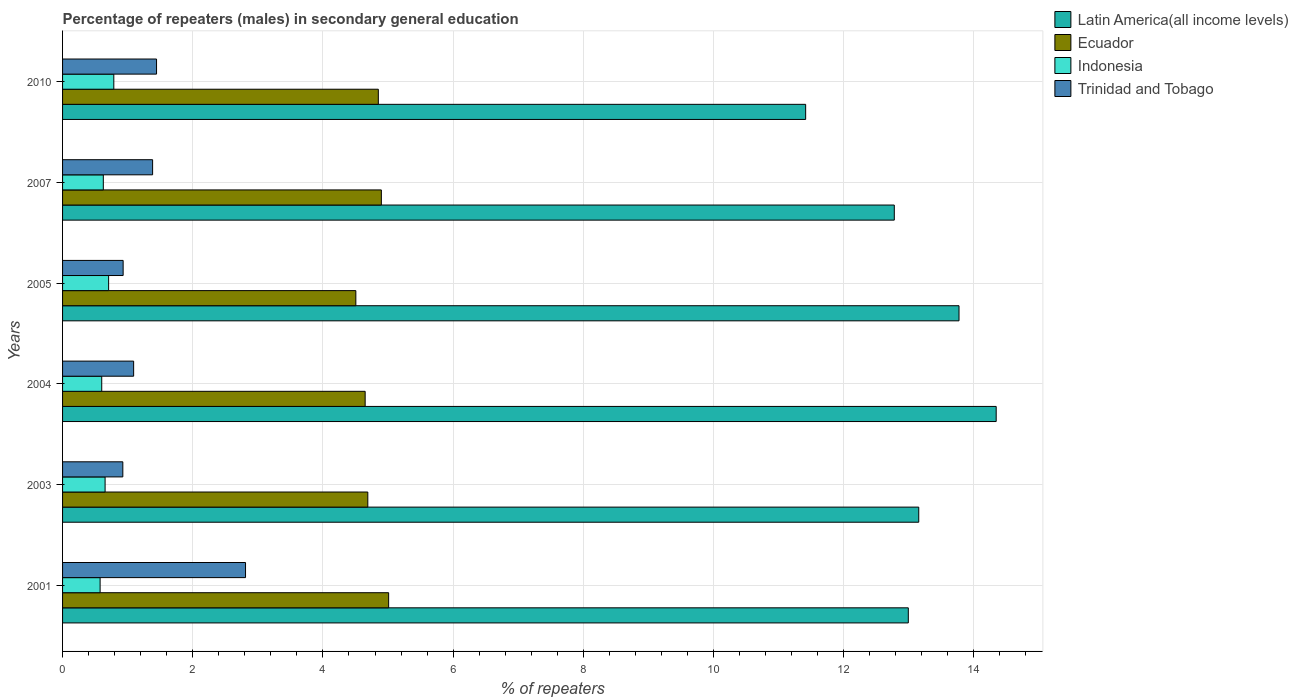How many bars are there on the 1st tick from the bottom?
Your answer should be very brief. 4. What is the label of the 4th group of bars from the top?
Offer a terse response. 2004. What is the percentage of male repeaters in Indonesia in 2004?
Provide a succinct answer. 0.6. Across all years, what is the maximum percentage of male repeaters in Indonesia?
Give a very brief answer. 0.79. Across all years, what is the minimum percentage of male repeaters in Trinidad and Tobago?
Make the answer very short. 0.93. In which year was the percentage of male repeaters in Indonesia maximum?
Offer a terse response. 2010. What is the total percentage of male repeaters in Indonesia in the graph?
Your response must be concise. 3.95. What is the difference between the percentage of male repeaters in Indonesia in 2004 and that in 2010?
Your answer should be very brief. -0.19. What is the difference between the percentage of male repeaters in Indonesia in 2004 and the percentage of male repeaters in Trinidad and Tobago in 2005?
Make the answer very short. -0.33. What is the average percentage of male repeaters in Ecuador per year?
Keep it short and to the point. 4.77. In the year 2005, what is the difference between the percentage of male repeaters in Indonesia and percentage of male repeaters in Latin America(all income levels)?
Offer a very short reply. -13.06. What is the ratio of the percentage of male repeaters in Trinidad and Tobago in 2005 to that in 2010?
Your answer should be compact. 0.64. Is the percentage of male repeaters in Trinidad and Tobago in 2003 less than that in 2005?
Provide a succinct answer. Yes. What is the difference between the highest and the second highest percentage of male repeaters in Ecuador?
Provide a succinct answer. 0.11. What is the difference between the highest and the lowest percentage of male repeaters in Indonesia?
Your response must be concise. 0.21. Is the sum of the percentage of male repeaters in Latin America(all income levels) in 2001 and 2010 greater than the maximum percentage of male repeaters in Ecuador across all years?
Offer a very short reply. Yes. Is it the case that in every year, the sum of the percentage of male repeaters in Indonesia and percentage of male repeaters in Trinidad and Tobago is greater than the sum of percentage of male repeaters in Latin America(all income levels) and percentage of male repeaters in Ecuador?
Your answer should be compact. No. What does the 4th bar from the top in 2005 represents?
Provide a succinct answer. Latin America(all income levels). What does the 2nd bar from the bottom in 2001 represents?
Ensure brevity in your answer.  Ecuador. Is it the case that in every year, the sum of the percentage of male repeaters in Ecuador and percentage of male repeaters in Latin America(all income levels) is greater than the percentage of male repeaters in Trinidad and Tobago?
Your answer should be compact. Yes. Are the values on the major ticks of X-axis written in scientific E-notation?
Keep it short and to the point. No. Does the graph contain grids?
Give a very brief answer. Yes. Where does the legend appear in the graph?
Your answer should be compact. Top right. How many legend labels are there?
Your answer should be very brief. 4. What is the title of the graph?
Make the answer very short. Percentage of repeaters (males) in secondary general education. Does "Sint Maarten (Dutch part)" appear as one of the legend labels in the graph?
Ensure brevity in your answer.  No. What is the label or title of the X-axis?
Your response must be concise. % of repeaters. What is the % of repeaters of Latin America(all income levels) in 2001?
Your response must be concise. 12.99. What is the % of repeaters of Ecuador in 2001?
Your answer should be very brief. 5.01. What is the % of repeaters in Indonesia in 2001?
Offer a terse response. 0.58. What is the % of repeaters in Trinidad and Tobago in 2001?
Your answer should be very brief. 2.81. What is the % of repeaters in Latin America(all income levels) in 2003?
Give a very brief answer. 13.15. What is the % of repeaters in Ecuador in 2003?
Offer a terse response. 4.69. What is the % of repeaters in Indonesia in 2003?
Give a very brief answer. 0.65. What is the % of repeaters in Trinidad and Tobago in 2003?
Offer a terse response. 0.93. What is the % of repeaters in Latin America(all income levels) in 2004?
Ensure brevity in your answer.  14.34. What is the % of repeaters of Ecuador in 2004?
Offer a very short reply. 4.65. What is the % of repeaters in Indonesia in 2004?
Give a very brief answer. 0.6. What is the % of repeaters in Trinidad and Tobago in 2004?
Provide a short and direct response. 1.09. What is the % of repeaters in Latin America(all income levels) in 2005?
Make the answer very short. 13.77. What is the % of repeaters in Ecuador in 2005?
Give a very brief answer. 4.51. What is the % of repeaters of Indonesia in 2005?
Provide a succinct answer. 0.71. What is the % of repeaters in Trinidad and Tobago in 2005?
Ensure brevity in your answer.  0.93. What is the % of repeaters in Latin America(all income levels) in 2007?
Give a very brief answer. 12.78. What is the % of repeaters of Ecuador in 2007?
Offer a terse response. 4.9. What is the % of repeaters of Indonesia in 2007?
Your response must be concise. 0.63. What is the % of repeaters of Trinidad and Tobago in 2007?
Keep it short and to the point. 1.38. What is the % of repeaters of Latin America(all income levels) in 2010?
Your response must be concise. 11.42. What is the % of repeaters of Ecuador in 2010?
Your response must be concise. 4.85. What is the % of repeaters in Indonesia in 2010?
Make the answer very short. 0.79. What is the % of repeaters of Trinidad and Tobago in 2010?
Provide a succinct answer. 1.44. Across all years, what is the maximum % of repeaters of Latin America(all income levels)?
Ensure brevity in your answer.  14.34. Across all years, what is the maximum % of repeaters in Ecuador?
Provide a succinct answer. 5.01. Across all years, what is the maximum % of repeaters of Indonesia?
Your answer should be compact. 0.79. Across all years, what is the maximum % of repeaters in Trinidad and Tobago?
Keep it short and to the point. 2.81. Across all years, what is the minimum % of repeaters of Latin America(all income levels)?
Your response must be concise. 11.42. Across all years, what is the minimum % of repeaters of Ecuador?
Offer a terse response. 4.51. Across all years, what is the minimum % of repeaters of Indonesia?
Offer a very short reply. 0.58. Across all years, what is the minimum % of repeaters in Trinidad and Tobago?
Provide a succinct answer. 0.93. What is the total % of repeaters of Latin America(all income levels) in the graph?
Your answer should be very brief. 78.45. What is the total % of repeaters of Ecuador in the graph?
Ensure brevity in your answer.  28.6. What is the total % of repeaters in Indonesia in the graph?
Provide a short and direct response. 3.95. What is the total % of repeaters of Trinidad and Tobago in the graph?
Ensure brevity in your answer.  8.59. What is the difference between the % of repeaters in Latin America(all income levels) in 2001 and that in 2003?
Give a very brief answer. -0.16. What is the difference between the % of repeaters of Ecuador in 2001 and that in 2003?
Offer a terse response. 0.32. What is the difference between the % of repeaters of Indonesia in 2001 and that in 2003?
Your answer should be very brief. -0.08. What is the difference between the % of repeaters in Trinidad and Tobago in 2001 and that in 2003?
Your answer should be compact. 1.89. What is the difference between the % of repeaters of Latin America(all income levels) in 2001 and that in 2004?
Offer a very short reply. -1.35. What is the difference between the % of repeaters in Ecuador in 2001 and that in 2004?
Your answer should be compact. 0.36. What is the difference between the % of repeaters in Indonesia in 2001 and that in 2004?
Provide a succinct answer. -0.03. What is the difference between the % of repeaters of Trinidad and Tobago in 2001 and that in 2004?
Your response must be concise. 1.72. What is the difference between the % of repeaters in Latin America(all income levels) in 2001 and that in 2005?
Provide a short and direct response. -0.78. What is the difference between the % of repeaters in Ecuador in 2001 and that in 2005?
Offer a very short reply. 0.5. What is the difference between the % of repeaters in Indonesia in 2001 and that in 2005?
Give a very brief answer. -0.13. What is the difference between the % of repeaters in Trinidad and Tobago in 2001 and that in 2005?
Ensure brevity in your answer.  1.88. What is the difference between the % of repeaters of Latin America(all income levels) in 2001 and that in 2007?
Provide a short and direct response. 0.22. What is the difference between the % of repeaters of Ecuador in 2001 and that in 2007?
Keep it short and to the point. 0.11. What is the difference between the % of repeaters in Indonesia in 2001 and that in 2007?
Provide a short and direct response. -0.05. What is the difference between the % of repeaters in Trinidad and Tobago in 2001 and that in 2007?
Your answer should be compact. 1.43. What is the difference between the % of repeaters in Latin America(all income levels) in 2001 and that in 2010?
Ensure brevity in your answer.  1.58. What is the difference between the % of repeaters of Ecuador in 2001 and that in 2010?
Your answer should be compact. 0.16. What is the difference between the % of repeaters of Indonesia in 2001 and that in 2010?
Keep it short and to the point. -0.21. What is the difference between the % of repeaters in Trinidad and Tobago in 2001 and that in 2010?
Ensure brevity in your answer.  1.37. What is the difference between the % of repeaters in Latin America(all income levels) in 2003 and that in 2004?
Offer a terse response. -1.19. What is the difference between the % of repeaters of Ecuador in 2003 and that in 2004?
Your answer should be compact. 0.04. What is the difference between the % of repeaters of Indonesia in 2003 and that in 2004?
Provide a succinct answer. 0.05. What is the difference between the % of repeaters in Trinidad and Tobago in 2003 and that in 2004?
Your answer should be very brief. -0.17. What is the difference between the % of repeaters in Latin America(all income levels) in 2003 and that in 2005?
Provide a succinct answer. -0.62. What is the difference between the % of repeaters of Ecuador in 2003 and that in 2005?
Make the answer very short. 0.18. What is the difference between the % of repeaters in Indonesia in 2003 and that in 2005?
Keep it short and to the point. -0.05. What is the difference between the % of repeaters in Trinidad and Tobago in 2003 and that in 2005?
Offer a very short reply. -0. What is the difference between the % of repeaters in Latin America(all income levels) in 2003 and that in 2007?
Your answer should be very brief. 0.38. What is the difference between the % of repeaters of Ecuador in 2003 and that in 2007?
Your answer should be compact. -0.21. What is the difference between the % of repeaters in Indonesia in 2003 and that in 2007?
Your response must be concise. 0.03. What is the difference between the % of repeaters of Trinidad and Tobago in 2003 and that in 2007?
Your answer should be very brief. -0.46. What is the difference between the % of repeaters in Latin America(all income levels) in 2003 and that in 2010?
Offer a terse response. 1.74. What is the difference between the % of repeaters in Ecuador in 2003 and that in 2010?
Your response must be concise. -0.16. What is the difference between the % of repeaters in Indonesia in 2003 and that in 2010?
Ensure brevity in your answer.  -0.13. What is the difference between the % of repeaters of Trinidad and Tobago in 2003 and that in 2010?
Give a very brief answer. -0.52. What is the difference between the % of repeaters in Latin America(all income levels) in 2004 and that in 2005?
Provide a succinct answer. 0.57. What is the difference between the % of repeaters of Ecuador in 2004 and that in 2005?
Your answer should be compact. 0.14. What is the difference between the % of repeaters in Indonesia in 2004 and that in 2005?
Provide a succinct answer. -0.11. What is the difference between the % of repeaters of Trinidad and Tobago in 2004 and that in 2005?
Provide a succinct answer. 0.16. What is the difference between the % of repeaters in Latin America(all income levels) in 2004 and that in 2007?
Keep it short and to the point. 1.57. What is the difference between the % of repeaters of Ecuador in 2004 and that in 2007?
Make the answer very short. -0.25. What is the difference between the % of repeaters of Indonesia in 2004 and that in 2007?
Make the answer very short. -0.02. What is the difference between the % of repeaters of Trinidad and Tobago in 2004 and that in 2007?
Provide a succinct answer. -0.29. What is the difference between the % of repeaters of Latin America(all income levels) in 2004 and that in 2010?
Offer a very short reply. 2.93. What is the difference between the % of repeaters in Ecuador in 2004 and that in 2010?
Keep it short and to the point. -0.2. What is the difference between the % of repeaters in Indonesia in 2004 and that in 2010?
Your answer should be compact. -0.19. What is the difference between the % of repeaters in Trinidad and Tobago in 2004 and that in 2010?
Your answer should be very brief. -0.35. What is the difference between the % of repeaters in Latin America(all income levels) in 2005 and that in 2007?
Offer a very short reply. 0.99. What is the difference between the % of repeaters in Ecuador in 2005 and that in 2007?
Your answer should be very brief. -0.39. What is the difference between the % of repeaters of Indonesia in 2005 and that in 2007?
Make the answer very short. 0.08. What is the difference between the % of repeaters in Trinidad and Tobago in 2005 and that in 2007?
Provide a short and direct response. -0.45. What is the difference between the % of repeaters of Latin America(all income levels) in 2005 and that in 2010?
Make the answer very short. 2.36. What is the difference between the % of repeaters of Ecuador in 2005 and that in 2010?
Your answer should be very brief. -0.35. What is the difference between the % of repeaters of Indonesia in 2005 and that in 2010?
Your response must be concise. -0.08. What is the difference between the % of repeaters of Trinidad and Tobago in 2005 and that in 2010?
Your response must be concise. -0.51. What is the difference between the % of repeaters of Latin America(all income levels) in 2007 and that in 2010?
Offer a terse response. 1.36. What is the difference between the % of repeaters in Ecuador in 2007 and that in 2010?
Provide a short and direct response. 0.05. What is the difference between the % of repeaters of Indonesia in 2007 and that in 2010?
Provide a short and direct response. -0.16. What is the difference between the % of repeaters of Trinidad and Tobago in 2007 and that in 2010?
Your answer should be compact. -0.06. What is the difference between the % of repeaters of Latin America(all income levels) in 2001 and the % of repeaters of Ecuador in 2003?
Your answer should be compact. 8.3. What is the difference between the % of repeaters of Latin America(all income levels) in 2001 and the % of repeaters of Indonesia in 2003?
Ensure brevity in your answer.  12.34. What is the difference between the % of repeaters of Latin America(all income levels) in 2001 and the % of repeaters of Trinidad and Tobago in 2003?
Your response must be concise. 12.07. What is the difference between the % of repeaters in Ecuador in 2001 and the % of repeaters in Indonesia in 2003?
Offer a terse response. 4.36. What is the difference between the % of repeaters in Ecuador in 2001 and the % of repeaters in Trinidad and Tobago in 2003?
Your response must be concise. 4.08. What is the difference between the % of repeaters in Indonesia in 2001 and the % of repeaters in Trinidad and Tobago in 2003?
Your response must be concise. -0.35. What is the difference between the % of repeaters in Latin America(all income levels) in 2001 and the % of repeaters in Ecuador in 2004?
Your answer should be compact. 8.34. What is the difference between the % of repeaters in Latin America(all income levels) in 2001 and the % of repeaters in Indonesia in 2004?
Your response must be concise. 12.39. What is the difference between the % of repeaters in Latin America(all income levels) in 2001 and the % of repeaters in Trinidad and Tobago in 2004?
Keep it short and to the point. 11.9. What is the difference between the % of repeaters in Ecuador in 2001 and the % of repeaters in Indonesia in 2004?
Keep it short and to the point. 4.41. What is the difference between the % of repeaters of Ecuador in 2001 and the % of repeaters of Trinidad and Tobago in 2004?
Offer a very short reply. 3.92. What is the difference between the % of repeaters in Indonesia in 2001 and the % of repeaters in Trinidad and Tobago in 2004?
Keep it short and to the point. -0.52. What is the difference between the % of repeaters of Latin America(all income levels) in 2001 and the % of repeaters of Ecuador in 2005?
Keep it short and to the point. 8.49. What is the difference between the % of repeaters of Latin America(all income levels) in 2001 and the % of repeaters of Indonesia in 2005?
Your answer should be compact. 12.28. What is the difference between the % of repeaters in Latin America(all income levels) in 2001 and the % of repeaters in Trinidad and Tobago in 2005?
Ensure brevity in your answer.  12.06. What is the difference between the % of repeaters of Ecuador in 2001 and the % of repeaters of Indonesia in 2005?
Make the answer very short. 4.3. What is the difference between the % of repeaters of Ecuador in 2001 and the % of repeaters of Trinidad and Tobago in 2005?
Your answer should be very brief. 4.08. What is the difference between the % of repeaters in Indonesia in 2001 and the % of repeaters in Trinidad and Tobago in 2005?
Provide a short and direct response. -0.35. What is the difference between the % of repeaters of Latin America(all income levels) in 2001 and the % of repeaters of Ecuador in 2007?
Provide a succinct answer. 8.1. What is the difference between the % of repeaters in Latin America(all income levels) in 2001 and the % of repeaters in Indonesia in 2007?
Ensure brevity in your answer.  12.37. What is the difference between the % of repeaters in Latin America(all income levels) in 2001 and the % of repeaters in Trinidad and Tobago in 2007?
Make the answer very short. 11.61. What is the difference between the % of repeaters in Ecuador in 2001 and the % of repeaters in Indonesia in 2007?
Your response must be concise. 4.38. What is the difference between the % of repeaters in Ecuador in 2001 and the % of repeaters in Trinidad and Tobago in 2007?
Offer a terse response. 3.63. What is the difference between the % of repeaters in Indonesia in 2001 and the % of repeaters in Trinidad and Tobago in 2007?
Offer a terse response. -0.81. What is the difference between the % of repeaters in Latin America(all income levels) in 2001 and the % of repeaters in Ecuador in 2010?
Offer a terse response. 8.14. What is the difference between the % of repeaters of Latin America(all income levels) in 2001 and the % of repeaters of Indonesia in 2010?
Provide a short and direct response. 12.21. What is the difference between the % of repeaters in Latin America(all income levels) in 2001 and the % of repeaters in Trinidad and Tobago in 2010?
Your answer should be very brief. 11.55. What is the difference between the % of repeaters in Ecuador in 2001 and the % of repeaters in Indonesia in 2010?
Your response must be concise. 4.22. What is the difference between the % of repeaters of Ecuador in 2001 and the % of repeaters of Trinidad and Tobago in 2010?
Your answer should be compact. 3.57. What is the difference between the % of repeaters of Indonesia in 2001 and the % of repeaters of Trinidad and Tobago in 2010?
Your answer should be very brief. -0.87. What is the difference between the % of repeaters of Latin America(all income levels) in 2003 and the % of repeaters of Ecuador in 2004?
Ensure brevity in your answer.  8.5. What is the difference between the % of repeaters in Latin America(all income levels) in 2003 and the % of repeaters in Indonesia in 2004?
Offer a very short reply. 12.55. What is the difference between the % of repeaters in Latin America(all income levels) in 2003 and the % of repeaters in Trinidad and Tobago in 2004?
Ensure brevity in your answer.  12.06. What is the difference between the % of repeaters of Ecuador in 2003 and the % of repeaters of Indonesia in 2004?
Provide a succinct answer. 4.09. What is the difference between the % of repeaters in Ecuador in 2003 and the % of repeaters in Trinidad and Tobago in 2004?
Provide a succinct answer. 3.6. What is the difference between the % of repeaters of Indonesia in 2003 and the % of repeaters of Trinidad and Tobago in 2004?
Make the answer very short. -0.44. What is the difference between the % of repeaters of Latin America(all income levels) in 2003 and the % of repeaters of Ecuador in 2005?
Give a very brief answer. 8.65. What is the difference between the % of repeaters of Latin America(all income levels) in 2003 and the % of repeaters of Indonesia in 2005?
Give a very brief answer. 12.45. What is the difference between the % of repeaters in Latin America(all income levels) in 2003 and the % of repeaters in Trinidad and Tobago in 2005?
Your answer should be very brief. 12.22. What is the difference between the % of repeaters of Ecuador in 2003 and the % of repeaters of Indonesia in 2005?
Your answer should be very brief. 3.98. What is the difference between the % of repeaters in Ecuador in 2003 and the % of repeaters in Trinidad and Tobago in 2005?
Make the answer very short. 3.76. What is the difference between the % of repeaters of Indonesia in 2003 and the % of repeaters of Trinidad and Tobago in 2005?
Provide a short and direct response. -0.28. What is the difference between the % of repeaters in Latin America(all income levels) in 2003 and the % of repeaters in Ecuador in 2007?
Provide a short and direct response. 8.26. What is the difference between the % of repeaters of Latin America(all income levels) in 2003 and the % of repeaters of Indonesia in 2007?
Offer a very short reply. 12.53. What is the difference between the % of repeaters in Latin America(all income levels) in 2003 and the % of repeaters in Trinidad and Tobago in 2007?
Offer a very short reply. 11.77. What is the difference between the % of repeaters in Ecuador in 2003 and the % of repeaters in Indonesia in 2007?
Provide a succinct answer. 4.06. What is the difference between the % of repeaters in Ecuador in 2003 and the % of repeaters in Trinidad and Tobago in 2007?
Your answer should be compact. 3.31. What is the difference between the % of repeaters of Indonesia in 2003 and the % of repeaters of Trinidad and Tobago in 2007?
Keep it short and to the point. -0.73. What is the difference between the % of repeaters of Latin America(all income levels) in 2003 and the % of repeaters of Ecuador in 2010?
Your response must be concise. 8.3. What is the difference between the % of repeaters of Latin America(all income levels) in 2003 and the % of repeaters of Indonesia in 2010?
Your answer should be compact. 12.37. What is the difference between the % of repeaters of Latin America(all income levels) in 2003 and the % of repeaters of Trinidad and Tobago in 2010?
Keep it short and to the point. 11.71. What is the difference between the % of repeaters in Ecuador in 2003 and the % of repeaters in Indonesia in 2010?
Provide a succinct answer. 3.9. What is the difference between the % of repeaters in Ecuador in 2003 and the % of repeaters in Trinidad and Tobago in 2010?
Your answer should be compact. 3.25. What is the difference between the % of repeaters of Indonesia in 2003 and the % of repeaters of Trinidad and Tobago in 2010?
Offer a terse response. -0.79. What is the difference between the % of repeaters in Latin America(all income levels) in 2004 and the % of repeaters in Ecuador in 2005?
Offer a very short reply. 9.84. What is the difference between the % of repeaters in Latin America(all income levels) in 2004 and the % of repeaters in Indonesia in 2005?
Make the answer very short. 13.63. What is the difference between the % of repeaters in Latin America(all income levels) in 2004 and the % of repeaters in Trinidad and Tobago in 2005?
Ensure brevity in your answer.  13.41. What is the difference between the % of repeaters in Ecuador in 2004 and the % of repeaters in Indonesia in 2005?
Your response must be concise. 3.94. What is the difference between the % of repeaters of Ecuador in 2004 and the % of repeaters of Trinidad and Tobago in 2005?
Ensure brevity in your answer.  3.72. What is the difference between the % of repeaters in Indonesia in 2004 and the % of repeaters in Trinidad and Tobago in 2005?
Provide a succinct answer. -0.33. What is the difference between the % of repeaters in Latin America(all income levels) in 2004 and the % of repeaters in Ecuador in 2007?
Provide a succinct answer. 9.45. What is the difference between the % of repeaters in Latin America(all income levels) in 2004 and the % of repeaters in Indonesia in 2007?
Your response must be concise. 13.72. What is the difference between the % of repeaters in Latin America(all income levels) in 2004 and the % of repeaters in Trinidad and Tobago in 2007?
Keep it short and to the point. 12.96. What is the difference between the % of repeaters of Ecuador in 2004 and the % of repeaters of Indonesia in 2007?
Keep it short and to the point. 4.02. What is the difference between the % of repeaters of Ecuador in 2004 and the % of repeaters of Trinidad and Tobago in 2007?
Offer a terse response. 3.27. What is the difference between the % of repeaters of Indonesia in 2004 and the % of repeaters of Trinidad and Tobago in 2007?
Make the answer very short. -0.78. What is the difference between the % of repeaters in Latin America(all income levels) in 2004 and the % of repeaters in Ecuador in 2010?
Provide a succinct answer. 9.49. What is the difference between the % of repeaters of Latin America(all income levels) in 2004 and the % of repeaters of Indonesia in 2010?
Your answer should be very brief. 13.56. What is the difference between the % of repeaters of Latin America(all income levels) in 2004 and the % of repeaters of Trinidad and Tobago in 2010?
Offer a terse response. 12.9. What is the difference between the % of repeaters of Ecuador in 2004 and the % of repeaters of Indonesia in 2010?
Give a very brief answer. 3.86. What is the difference between the % of repeaters in Ecuador in 2004 and the % of repeaters in Trinidad and Tobago in 2010?
Your answer should be very brief. 3.2. What is the difference between the % of repeaters of Indonesia in 2004 and the % of repeaters of Trinidad and Tobago in 2010?
Make the answer very short. -0.84. What is the difference between the % of repeaters in Latin America(all income levels) in 2005 and the % of repeaters in Ecuador in 2007?
Offer a terse response. 8.87. What is the difference between the % of repeaters of Latin America(all income levels) in 2005 and the % of repeaters of Indonesia in 2007?
Offer a terse response. 13.15. What is the difference between the % of repeaters of Latin America(all income levels) in 2005 and the % of repeaters of Trinidad and Tobago in 2007?
Keep it short and to the point. 12.39. What is the difference between the % of repeaters in Ecuador in 2005 and the % of repeaters in Indonesia in 2007?
Provide a short and direct response. 3.88. What is the difference between the % of repeaters in Ecuador in 2005 and the % of repeaters in Trinidad and Tobago in 2007?
Your answer should be very brief. 3.12. What is the difference between the % of repeaters in Indonesia in 2005 and the % of repeaters in Trinidad and Tobago in 2007?
Your response must be concise. -0.68. What is the difference between the % of repeaters of Latin America(all income levels) in 2005 and the % of repeaters of Ecuador in 2010?
Keep it short and to the point. 8.92. What is the difference between the % of repeaters of Latin America(all income levels) in 2005 and the % of repeaters of Indonesia in 2010?
Provide a short and direct response. 12.98. What is the difference between the % of repeaters in Latin America(all income levels) in 2005 and the % of repeaters in Trinidad and Tobago in 2010?
Offer a terse response. 12.33. What is the difference between the % of repeaters in Ecuador in 2005 and the % of repeaters in Indonesia in 2010?
Your answer should be compact. 3.72. What is the difference between the % of repeaters in Ecuador in 2005 and the % of repeaters in Trinidad and Tobago in 2010?
Offer a terse response. 3.06. What is the difference between the % of repeaters in Indonesia in 2005 and the % of repeaters in Trinidad and Tobago in 2010?
Give a very brief answer. -0.74. What is the difference between the % of repeaters of Latin America(all income levels) in 2007 and the % of repeaters of Ecuador in 2010?
Ensure brevity in your answer.  7.93. What is the difference between the % of repeaters of Latin America(all income levels) in 2007 and the % of repeaters of Indonesia in 2010?
Your answer should be very brief. 11.99. What is the difference between the % of repeaters of Latin America(all income levels) in 2007 and the % of repeaters of Trinidad and Tobago in 2010?
Make the answer very short. 11.33. What is the difference between the % of repeaters in Ecuador in 2007 and the % of repeaters in Indonesia in 2010?
Your answer should be compact. 4.11. What is the difference between the % of repeaters of Ecuador in 2007 and the % of repeaters of Trinidad and Tobago in 2010?
Keep it short and to the point. 3.45. What is the difference between the % of repeaters of Indonesia in 2007 and the % of repeaters of Trinidad and Tobago in 2010?
Offer a terse response. -0.82. What is the average % of repeaters in Latin America(all income levels) per year?
Provide a short and direct response. 13.08. What is the average % of repeaters of Ecuador per year?
Make the answer very short. 4.77. What is the average % of repeaters of Indonesia per year?
Make the answer very short. 0.66. What is the average % of repeaters in Trinidad and Tobago per year?
Your answer should be compact. 1.43. In the year 2001, what is the difference between the % of repeaters in Latin America(all income levels) and % of repeaters in Ecuador?
Provide a short and direct response. 7.98. In the year 2001, what is the difference between the % of repeaters in Latin America(all income levels) and % of repeaters in Indonesia?
Offer a terse response. 12.42. In the year 2001, what is the difference between the % of repeaters of Latin America(all income levels) and % of repeaters of Trinidad and Tobago?
Provide a succinct answer. 10.18. In the year 2001, what is the difference between the % of repeaters of Ecuador and % of repeaters of Indonesia?
Offer a very short reply. 4.43. In the year 2001, what is the difference between the % of repeaters of Ecuador and % of repeaters of Trinidad and Tobago?
Ensure brevity in your answer.  2.2. In the year 2001, what is the difference between the % of repeaters in Indonesia and % of repeaters in Trinidad and Tobago?
Make the answer very short. -2.23. In the year 2003, what is the difference between the % of repeaters in Latin America(all income levels) and % of repeaters in Ecuador?
Keep it short and to the point. 8.46. In the year 2003, what is the difference between the % of repeaters of Latin America(all income levels) and % of repeaters of Indonesia?
Your answer should be very brief. 12.5. In the year 2003, what is the difference between the % of repeaters in Latin America(all income levels) and % of repeaters in Trinidad and Tobago?
Your answer should be compact. 12.23. In the year 2003, what is the difference between the % of repeaters of Ecuador and % of repeaters of Indonesia?
Give a very brief answer. 4.04. In the year 2003, what is the difference between the % of repeaters of Ecuador and % of repeaters of Trinidad and Tobago?
Offer a very short reply. 3.76. In the year 2003, what is the difference between the % of repeaters in Indonesia and % of repeaters in Trinidad and Tobago?
Give a very brief answer. -0.27. In the year 2004, what is the difference between the % of repeaters of Latin America(all income levels) and % of repeaters of Ecuador?
Ensure brevity in your answer.  9.69. In the year 2004, what is the difference between the % of repeaters of Latin America(all income levels) and % of repeaters of Indonesia?
Offer a very short reply. 13.74. In the year 2004, what is the difference between the % of repeaters of Latin America(all income levels) and % of repeaters of Trinidad and Tobago?
Your answer should be compact. 13.25. In the year 2004, what is the difference between the % of repeaters in Ecuador and % of repeaters in Indonesia?
Provide a succinct answer. 4.05. In the year 2004, what is the difference between the % of repeaters in Ecuador and % of repeaters in Trinidad and Tobago?
Give a very brief answer. 3.56. In the year 2004, what is the difference between the % of repeaters of Indonesia and % of repeaters of Trinidad and Tobago?
Give a very brief answer. -0.49. In the year 2005, what is the difference between the % of repeaters in Latin America(all income levels) and % of repeaters in Ecuador?
Your response must be concise. 9.27. In the year 2005, what is the difference between the % of repeaters of Latin America(all income levels) and % of repeaters of Indonesia?
Give a very brief answer. 13.06. In the year 2005, what is the difference between the % of repeaters of Latin America(all income levels) and % of repeaters of Trinidad and Tobago?
Your response must be concise. 12.84. In the year 2005, what is the difference between the % of repeaters in Ecuador and % of repeaters in Indonesia?
Keep it short and to the point. 3.8. In the year 2005, what is the difference between the % of repeaters in Ecuador and % of repeaters in Trinidad and Tobago?
Offer a terse response. 3.58. In the year 2005, what is the difference between the % of repeaters in Indonesia and % of repeaters in Trinidad and Tobago?
Offer a very short reply. -0.22. In the year 2007, what is the difference between the % of repeaters in Latin America(all income levels) and % of repeaters in Ecuador?
Offer a terse response. 7.88. In the year 2007, what is the difference between the % of repeaters of Latin America(all income levels) and % of repeaters of Indonesia?
Your response must be concise. 12.15. In the year 2007, what is the difference between the % of repeaters in Latin America(all income levels) and % of repeaters in Trinidad and Tobago?
Make the answer very short. 11.39. In the year 2007, what is the difference between the % of repeaters of Ecuador and % of repeaters of Indonesia?
Make the answer very short. 4.27. In the year 2007, what is the difference between the % of repeaters of Ecuador and % of repeaters of Trinidad and Tobago?
Your answer should be compact. 3.51. In the year 2007, what is the difference between the % of repeaters of Indonesia and % of repeaters of Trinidad and Tobago?
Your response must be concise. -0.76. In the year 2010, what is the difference between the % of repeaters in Latin America(all income levels) and % of repeaters in Ecuador?
Keep it short and to the point. 6.57. In the year 2010, what is the difference between the % of repeaters in Latin America(all income levels) and % of repeaters in Indonesia?
Give a very brief answer. 10.63. In the year 2010, what is the difference between the % of repeaters of Latin America(all income levels) and % of repeaters of Trinidad and Tobago?
Make the answer very short. 9.97. In the year 2010, what is the difference between the % of repeaters of Ecuador and % of repeaters of Indonesia?
Ensure brevity in your answer.  4.06. In the year 2010, what is the difference between the % of repeaters in Ecuador and % of repeaters in Trinidad and Tobago?
Offer a terse response. 3.41. In the year 2010, what is the difference between the % of repeaters in Indonesia and % of repeaters in Trinidad and Tobago?
Make the answer very short. -0.66. What is the ratio of the % of repeaters of Ecuador in 2001 to that in 2003?
Offer a very short reply. 1.07. What is the ratio of the % of repeaters of Indonesia in 2001 to that in 2003?
Give a very brief answer. 0.88. What is the ratio of the % of repeaters in Trinidad and Tobago in 2001 to that in 2003?
Provide a short and direct response. 3.04. What is the ratio of the % of repeaters in Latin America(all income levels) in 2001 to that in 2004?
Your answer should be compact. 0.91. What is the ratio of the % of repeaters in Ecuador in 2001 to that in 2004?
Your answer should be very brief. 1.08. What is the ratio of the % of repeaters of Indonesia in 2001 to that in 2004?
Make the answer very short. 0.96. What is the ratio of the % of repeaters of Trinidad and Tobago in 2001 to that in 2004?
Offer a very short reply. 2.57. What is the ratio of the % of repeaters in Latin America(all income levels) in 2001 to that in 2005?
Give a very brief answer. 0.94. What is the ratio of the % of repeaters in Ecuador in 2001 to that in 2005?
Give a very brief answer. 1.11. What is the ratio of the % of repeaters of Indonesia in 2001 to that in 2005?
Give a very brief answer. 0.81. What is the ratio of the % of repeaters of Trinidad and Tobago in 2001 to that in 2005?
Your answer should be very brief. 3.02. What is the ratio of the % of repeaters in Latin America(all income levels) in 2001 to that in 2007?
Provide a succinct answer. 1.02. What is the ratio of the % of repeaters in Ecuador in 2001 to that in 2007?
Keep it short and to the point. 1.02. What is the ratio of the % of repeaters of Indonesia in 2001 to that in 2007?
Provide a short and direct response. 0.92. What is the ratio of the % of repeaters in Trinidad and Tobago in 2001 to that in 2007?
Provide a succinct answer. 2.03. What is the ratio of the % of repeaters in Latin America(all income levels) in 2001 to that in 2010?
Keep it short and to the point. 1.14. What is the ratio of the % of repeaters in Ecuador in 2001 to that in 2010?
Your answer should be very brief. 1.03. What is the ratio of the % of repeaters of Indonesia in 2001 to that in 2010?
Make the answer very short. 0.73. What is the ratio of the % of repeaters in Trinidad and Tobago in 2001 to that in 2010?
Offer a very short reply. 1.95. What is the ratio of the % of repeaters of Latin America(all income levels) in 2003 to that in 2004?
Ensure brevity in your answer.  0.92. What is the ratio of the % of repeaters of Ecuador in 2003 to that in 2004?
Provide a succinct answer. 1.01. What is the ratio of the % of repeaters in Indonesia in 2003 to that in 2004?
Make the answer very short. 1.09. What is the ratio of the % of repeaters of Trinidad and Tobago in 2003 to that in 2004?
Keep it short and to the point. 0.85. What is the ratio of the % of repeaters in Latin America(all income levels) in 2003 to that in 2005?
Ensure brevity in your answer.  0.96. What is the ratio of the % of repeaters in Ecuador in 2003 to that in 2005?
Provide a succinct answer. 1.04. What is the ratio of the % of repeaters in Indonesia in 2003 to that in 2005?
Your answer should be compact. 0.92. What is the ratio of the % of repeaters of Latin America(all income levels) in 2003 to that in 2007?
Ensure brevity in your answer.  1.03. What is the ratio of the % of repeaters in Ecuador in 2003 to that in 2007?
Provide a short and direct response. 0.96. What is the ratio of the % of repeaters of Indonesia in 2003 to that in 2007?
Provide a short and direct response. 1.04. What is the ratio of the % of repeaters in Trinidad and Tobago in 2003 to that in 2007?
Provide a succinct answer. 0.67. What is the ratio of the % of repeaters in Latin America(all income levels) in 2003 to that in 2010?
Your response must be concise. 1.15. What is the ratio of the % of repeaters in Ecuador in 2003 to that in 2010?
Ensure brevity in your answer.  0.97. What is the ratio of the % of repeaters in Indonesia in 2003 to that in 2010?
Provide a succinct answer. 0.83. What is the ratio of the % of repeaters of Trinidad and Tobago in 2003 to that in 2010?
Your answer should be compact. 0.64. What is the ratio of the % of repeaters of Latin America(all income levels) in 2004 to that in 2005?
Provide a succinct answer. 1.04. What is the ratio of the % of repeaters in Ecuador in 2004 to that in 2005?
Provide a succinct answer. 1.03. What is the ratio of the % of repeaters in Indonesia in 2004 to that in 2005?
Ensure brevity in your answer.  0.85. What is the ratio of the % of repeaters in Trinidad and Tobago in 2004 to that in 2005?
Your answer should be very brief. 1.17. What is the ratio of the % of repeaters of Latin America(all income levels) in 2004 to that in 2007?
Make the answer very short. 1.12. What is the ratio of the % of repeaters of Ecuador in 2004 to that in 2007?
Provide a short and direct response. 0.95. What is the ratio of the % of repeaters of Indonesia in 2004 to that in 2007?
Your response must be concise. 0.96. What is the ratio of the % of repeaters in Trinidad and Tobago in 2004 to that in 2007?
Ensure brevity in your answer.  0.79. What is the ratio of the % of repeaters of Latin America(all income levels) in 2004 to that in 2010?
Your answer should be very brief. 1.26. What is the ratio of the % of repeaters in Ecuador in 2004 to that in 2010?
Your response must be concise. 0.96. What is the ratio of the % of repeaters in Indonesia in 2004 to that in 2010?
Your answer should be compact. 0.76. What is the ratio of the % of repeaters in Trinidad and Tobago in 2004 to that in 2010?
Give a very brief answer. 0.76. What is the ratio of the % of repeaters in Latin America(all income levels) in 2005 to that in 2007?
Give a very brief answer. 1.08. What is the ratio of the % of repeaters in Ecuador in 2005 to that in 2007?
Give a very brief answer. 0.92. What is the ratio of the % of repeaters in Indonesia in 2005 to that in 2007?
Your answer should be compact. 1.13. What is the ratio of the % of repeaters of Trinidad and Tobago in 2005 to that in 2007?
Offer a very short reply. 0.67. What is the ratio of the % of repeaters of Latin America(all income levels) in 2005 to that in 2010?
Your response must be concise. 1.21. What is the ratio of the % of repeaters in Ecuador in 2005 to that in 2010?
Your answer should be compact. 0.93. What is the ratio of the % of repeaters of Indonesia in 2005 to that in 2010?
Give a very brief answer. 0.9. What is the ratio of the % of repeaters in Trinidad and Tobago in 2005 to that in 2010?
Provide a succinct answer. 0.64. What is the ratio of the % of repeaters in Latin America(all income levels) in 2007 to that in 2010?
Provide a short and direct response. 1.12. What is the ratio of the % of repeaters in Ecuador in 2007 to that in 2010?
Your answer should be compact. 1.01. What is the ratio of the % of repeaters of Indonesia in 2007 to that in 2010?
Provide a succinct answer. 0.8. What is the ratio of the % of repeaters of Trinidad and Tobago in 2007 to that in 2010?
Make the answer very short. 0.96. What is the difference between the highest and the second highest % of repeaters in Latin America(all income levels)?
Provide a succinct answer. 0.57. What is the difference between the highest and the second highest % of repeaters of Ecuador?
Provide a succinct answer. 0.11. What is the difference between the highest and the second highest % of repeaters in Indonesia?
Provide a succinct answer. 0.08. What is the difference between the highest and the second highest % of repeaters of Trinidad and Tobago?
Keep it short and to the point. 1.37. What is the difference between the highest and the lowest % of repeaters in Latin America(all income levels)?
Your response must be concise. 2.93. What is the difference between the highest and the lowest % of repeaters of Ecuador?
Provide a short and direct response. 0.5. What is the difference between the highest and the lowest % of repeaters in Indonesia?
Ensure brevity in your answer.  0.21. What is the difference between the highest and the lowest % of repeaters in Trinidad and Tobago?
Offer a terse response. 1.89. 